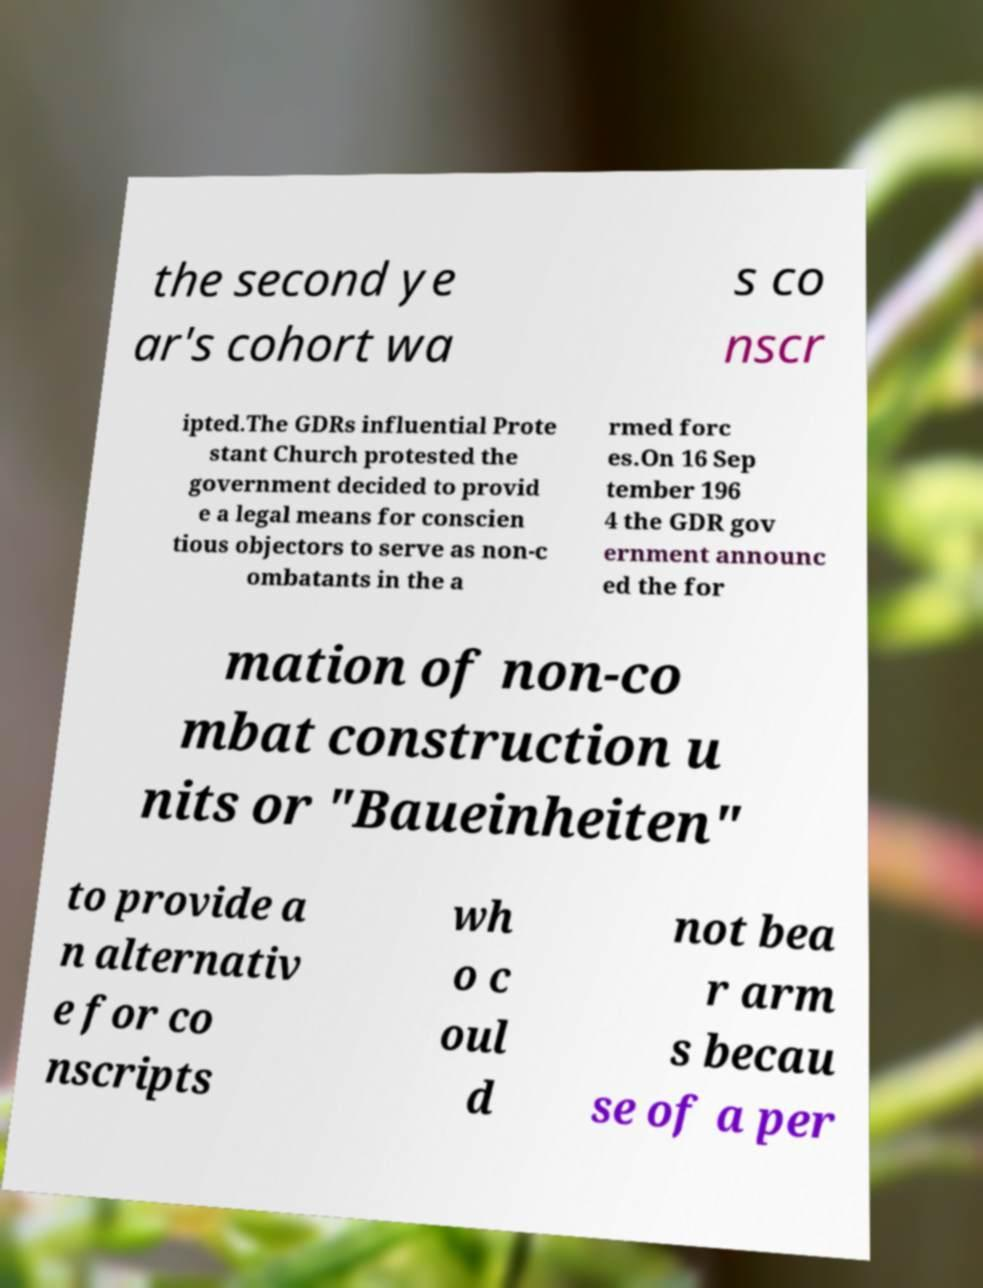For documentation purposes, I need the text within this image transcribed. Could you provide that? the second ye ar's cohort wa s co nscr ipted.The GDRs influential Prote stant Church protested the government decided to provid e a legal means for conscien tious objectors to serve as non-c ombatants in the a rmed forc es.On 16 Sep tember 196 4 the GDR gov ernment announc ed the for mation of non-co mbat construction u nits or "Baueinheiten" to provide a n alternativ e for co nscripts wh o c oul d not bea r arm s becau se of a per 